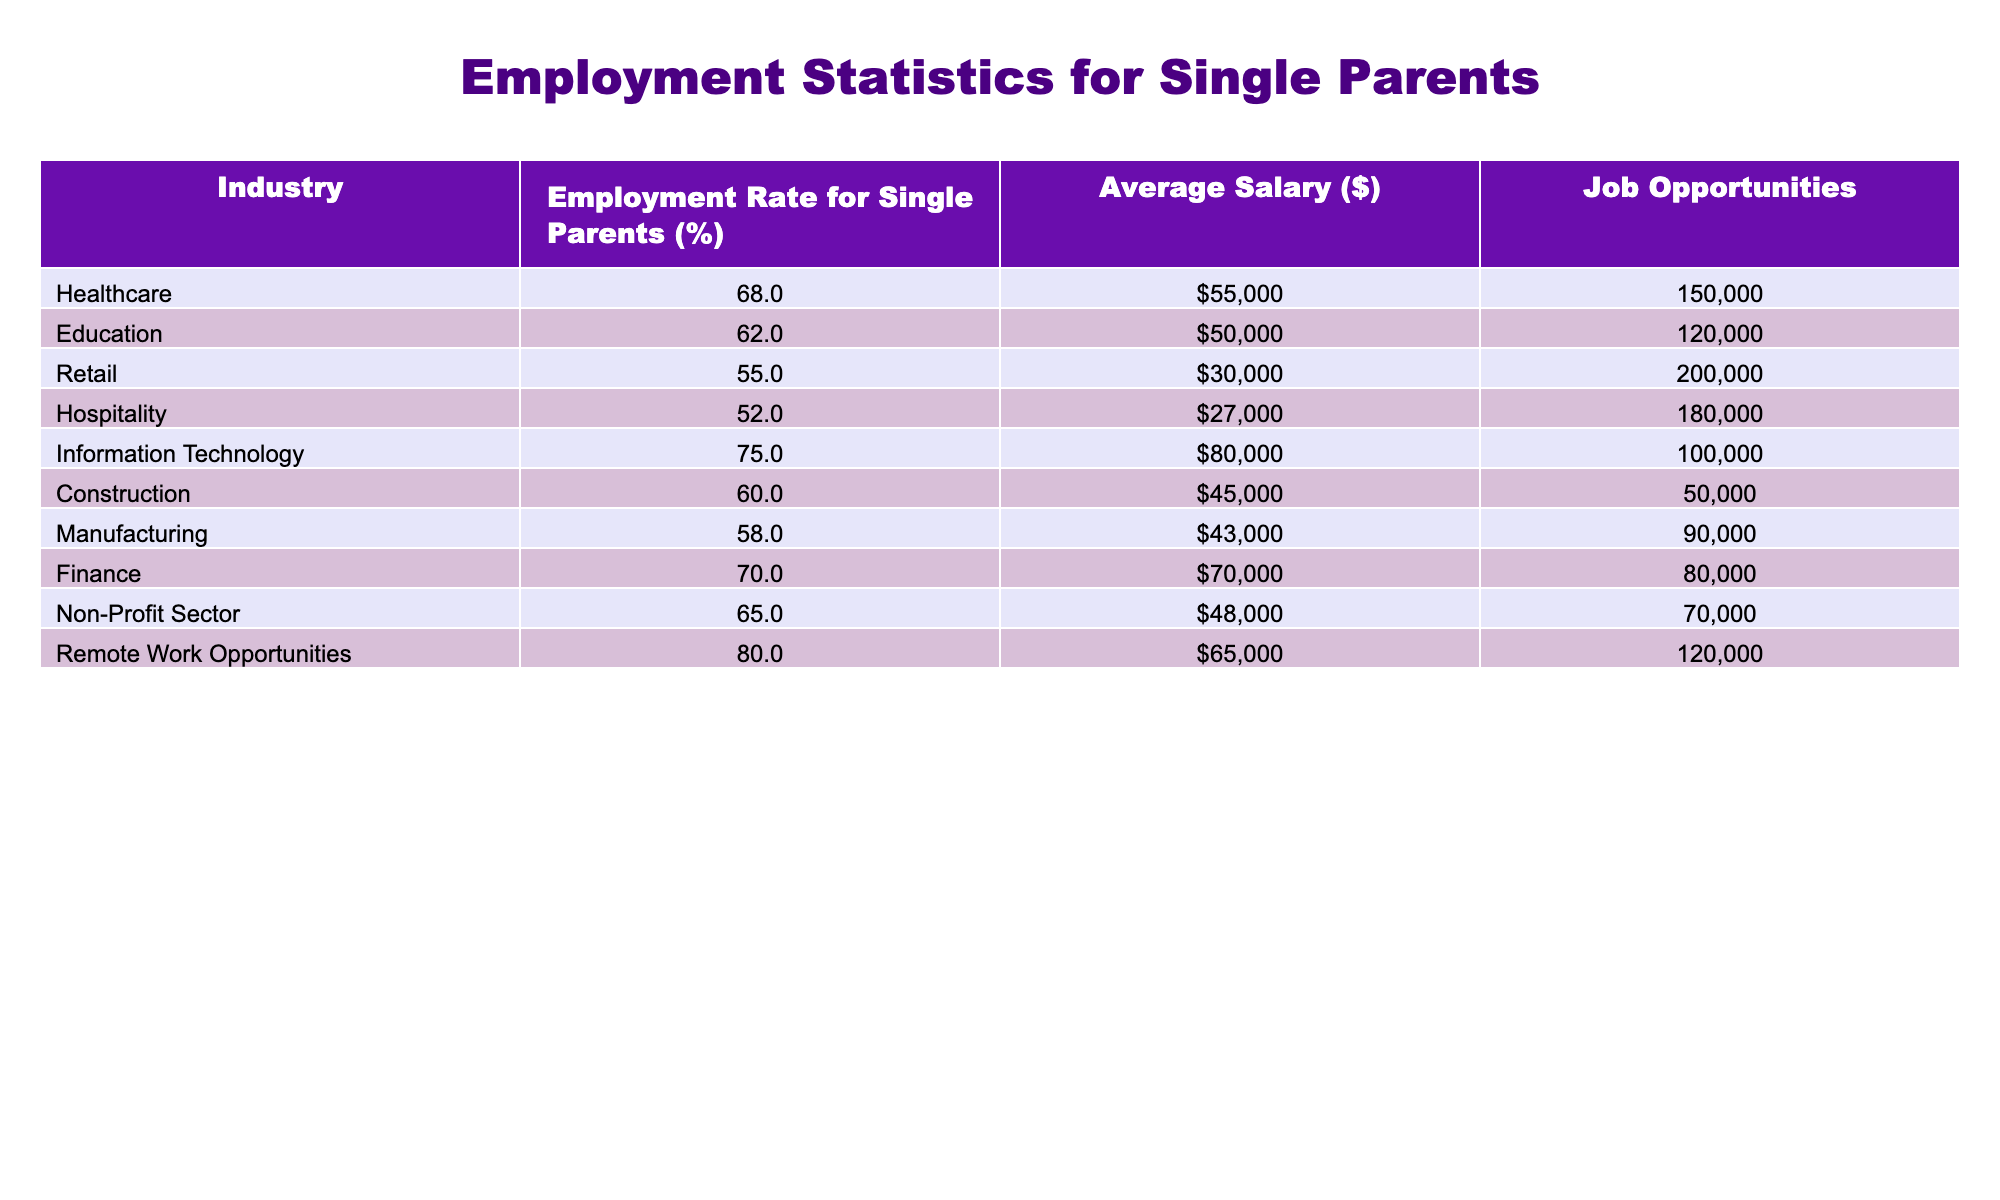What is the employment rate for single parents in the Information Technology industry? According to the table, the employment rate for single parents in the Information Technology industry is directly listed as 75%.
Answer: 75% Which industry offers the highest average salary for single parents? The table shows that the highest average salary for single parents is in Information Technology, listed at $80,000.
Answer: Information Technology What is the average employment rate across the Healthcare and Education industries? To find the average employment rate, we take the rates from Healthcare (68%) and Education (62%), sum them (68 + 62) = 130, and then divide by the number of industries (2) to get 130/2 = 65%.
Answer: 65% Are single parents in the Retail industry earning more than those in the Hospitality industry? Yes, the average salary for single parents in Retail is $30,000 while in the Hospitality industry, it is $27,000, indicating that those in Retail earn more.
Answer: Yes What is the total number of job opportunities available in the Non-Profit Sector and Healthcare combined? Adding the job opportunities in the Non-Profit Sector (70,000) and Healthcare (150,000) gives us a total of 220,000 job opportunities (70,000 + 150,000 = 220,000).
Answer: 220,000 What percentage of employment rates falls below 60% in this table? The employment rates below 60% are found in Retail (55%), Hospitality (52%), and Manufacturing (58%). There are three instances out of ten total entries, so (3/10)*100% gives us 30%.
Answer: 30% Which industries have an employment rate higher than 65%? The industries with an employment rate above 65% are Information Technology (75%), Finance (70%), and Healthcare (68%).
Answer: Information Technology, Finance, Healthcare What is the difference in employment rates between Remote Work Opportunities and the Construction industry? The employment rate for Remote Work Opportunities is 80%, and for Construction, it is 60%. The difference is calculated by subtracting the lower from the higher (80 - 60) = 20%.
Answer: 20% What is the median average salary of the industries listed? To find the median, we first need to organize the salaries in ascending order: $27,000, $30,000, $43,000, $45,000, $48,000, $50,000, $55,000, $60,000, $70,000, $80,000. The median is the average of the 5th and 6th numbers: (48,000 + 50,000)/2 = 49,000.
Answer: 49,000 